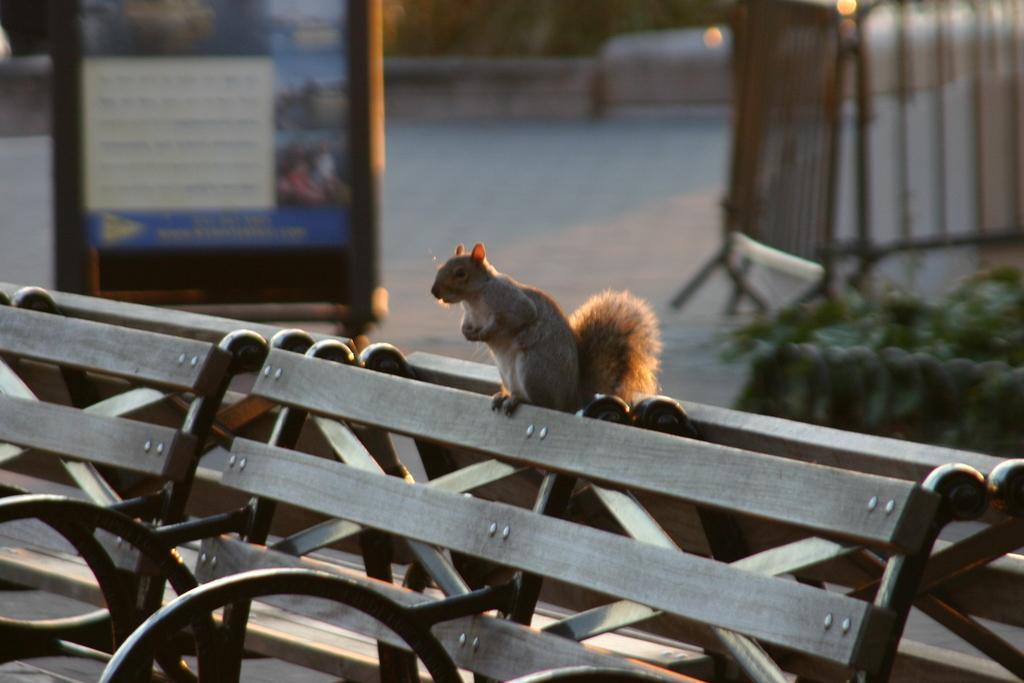Could you give a brief overview of what you see in this image? In the center of the image we can see a squirrel on the bench. In the background, we can see a banner, metal railing and group of plants. 